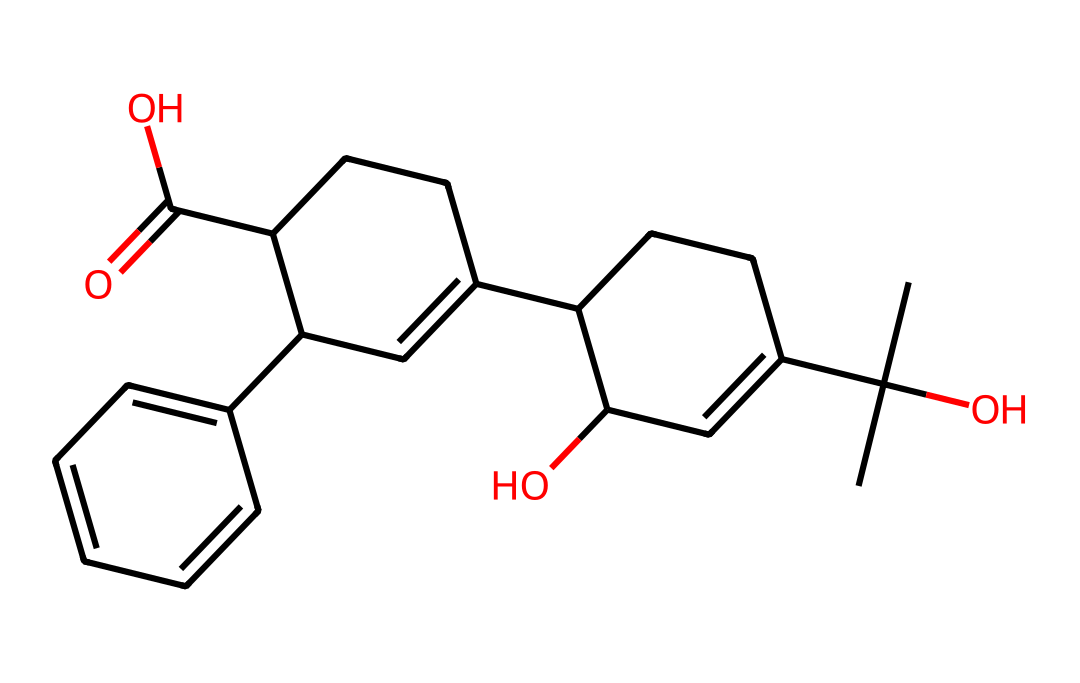What is the molecular formula of this compound? By counting the atoms in the chemical structure represented by the SMILES notation, we identify the types and quantities of each atom: there are 19 carbon (C) atoms, 28 hydrogen (H) atoms, and 4 oxygen (O) atoms. Thus, the molecular formula can be written as C19H28O4.
Answer: C19H28O4 How many double bonds are present in this structure? Analyzing the chemical structure, we note that double bonds are typically indicated by the "=" symbol in the SMILES representation. By examining the specific locations where double bonds occur, we find that there are 4 double bonds in total.
Answer: 4 What is the characteristic functional group in this compound? Looking at the structure, the presence of the carboxylic acid group (-COOH) is indicated by the presence of a carbonyl group (C=O) bonded to a hydroxyl group (-OH). This is significant in determining the compound's properties and potential biological activity.
Answer: carboxylic acid Does this compound have any chiral centers? A chiral center is typically a carbon atom that has four different substituents attached. By analyzing the carbon atoms in the given structure, we find several carbon atoms exhibiting this property, indicating that the compound possesses chiral centers.
Answer: yes What type of organic compound is represented by this structure? Examining the structure and its functional groups, we can categorize this compound based on its features. Given the presence of multiple functional groups, including the carboxylic acid and alcohols, we can classify the compound as a terpenoid or a related complex organic molecule.
Answer: terpenoid Which part of this molecule affects its therapeutic properties? Considering the therapeutic properties commonly associated with CBD oil, the key features include the specific functional groups and their arrangement, particularly the presence of the hydroxyl groups and the configuration around chiral centers, which influence how the molecule interacts with biological systems.
Answer: hydroxyl groups 